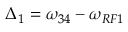Convert formula to latex. <formula><loc_0><loc_0><loc_500><loc_500>\Delta _ { 1 } = \omega _ { 3 4 } - \omega _ { R F 1 }</formula> 